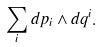<formula> <loc_0><loc_0><loc_500><loc_500>\sum _ { i } d p _ { i } \wedge d q ^ { i } .</formula> 